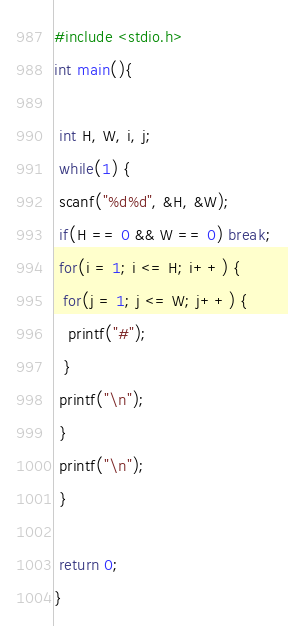<code> <loc_0><loc_0><loc_500><loc_500><_C_>#include <stdio.h>
int main(){
  
 int H, W, i, j;
 while(1) {
 scanf("%d%d", &H, &W);
 if(H == 0 && W == 0) break;
 for(i = 1; i <= H; i++) {
  for(j = 1; j <= W; j++) {
   printf("#");
  }
 printf("\n");
 }
 printf("\n");
 }
  
 return 0;
}</code> 